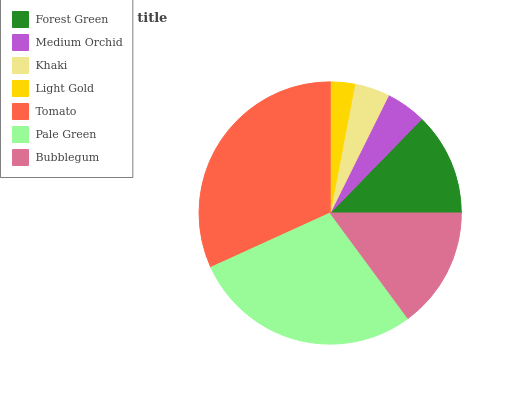Is Light Gold the minimum?
Answer yes or no. Yes. Is Tomato the maximum?
Answer yes or no. Yes. Is Medium Orchid the minimum?
Answer yes or no. No. Is Medium Orchid the maximum?
Answer yes or no. No. Is Forest Green greater than Medium Orchid?
Answer yes or no. Yes. Is Medium Orchid less than Forest Green?
Answer yes or no. Yes. Is Medium Orchid greater than Forest Green?
Answer yes or no. No. Is Forest Green less than Medium Orchid?
Answer yes or no. No. Is Forest Green the high median?
Answer yes or no. Yes. Is Forest Green the low median?
Answer yes or no. Yes. Is Bubblegum the high median?
Answer yes or no. No. Is Khaki the low median?
Answer yes or no. No. 